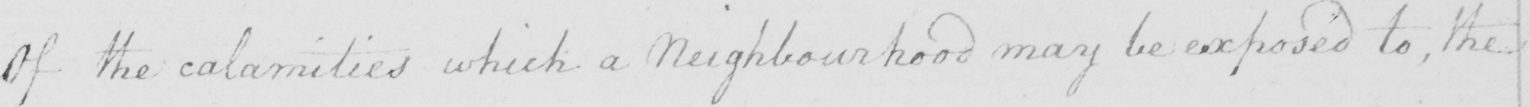What text is written in this handwritten line? Of the calamities which a Neighbourhood may be exposed to , the 